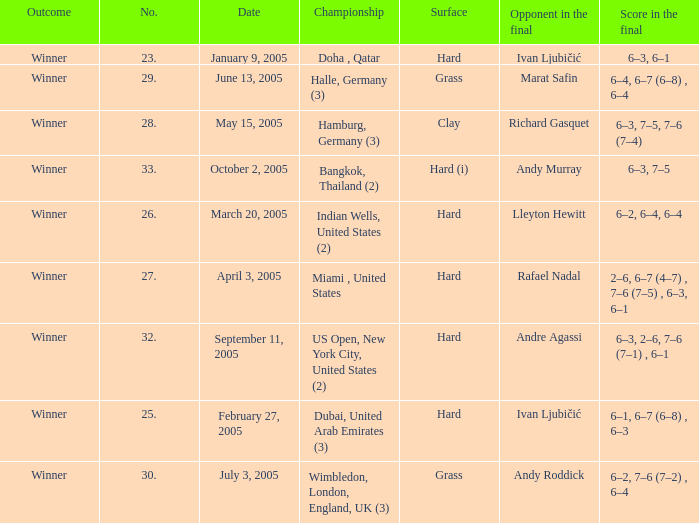Andy Roddick is the opponent in the final on what surface? Grass. 